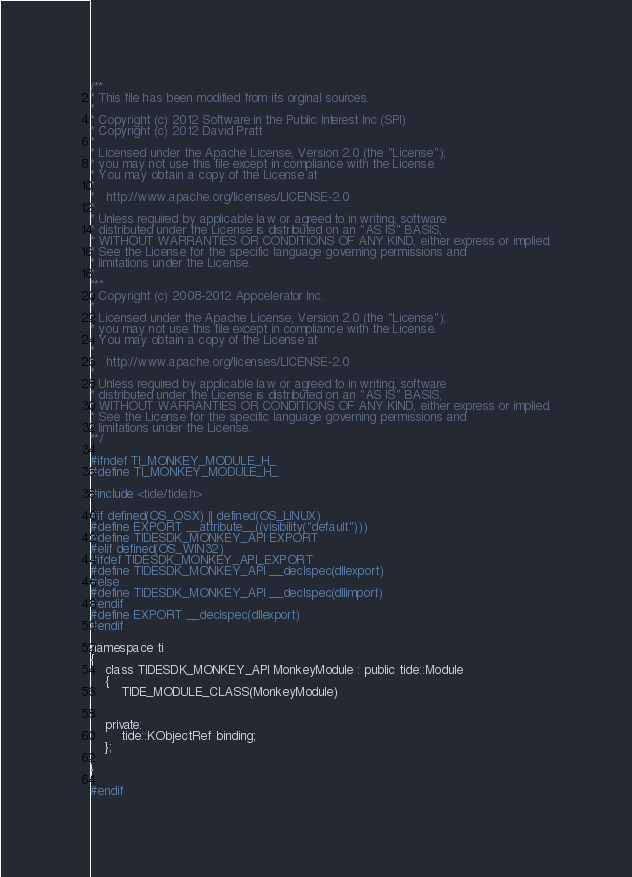<code> <loc_0><loc_0><loc_500><loc_500><_C_>/**
* This file has been modified from its orginal sources.
*
* Copyright (c) 2012 Software in the Public Interest Inc (SPI)
* Copyright (c) 2012 David Pratt
* 
* Licensed under the Apache License, Version 2.0 (the "License");
* you may not use this file except in compliance with the License.
* You may obtain a copy of the License at
*
*   http://www.apache.org/licenses/LICENSE-2.0
*
* Unless required by applicable law or agreed to in writing, software
* distributed under the License is distributed on an "AS IS" BASIS,
* WITHOUT WARRANTIES OR CONDITIONS OF ANY KIND, either express or implied.
* See the License for the specific language governing permissions and
* limitations under the License.
*
***
* Copyright (c) 2008-2012 Appcelerator Inc.
* 
* Licensed under the Apache License, Version 2.0 (the "License");
* you may not use this file except in compliance with the License.
* You may obtain a copy of the License at
*
*   http://www.apache.org/licenses/LICENSE-2.0
*
* Unless required by applicable law or agreed to in writing, software
* distributed under the License is distributed on an "AS IS" BASIS,
* WITHOUT WARRANTIES OR CONDITIONS OF ANY KIND, either express or implied.
* See the License for the specific language governing permissions and
* limitations under the License.
**/

#ifndef TI_MONKEY_MODULE_H_
#define TI_MONKEY_MODULE_H_

#include <tide/tide.h>

#if defined(OS_OSX) || defined(OS_LINUX)
#define EXPORT __attribute__((visibility("default")))
#define TIDESDK_MONKEY_API EXPORT
#elif defined(OS_WIN32)
#ifdef TIDESDK_MONKEY_API_EXPORT
#define TIDESDK_MONKEY_API __declspec(dllexport)
#else
#define TIDESDK_MONKEY_API __declspec(dllimport)
#endif
#define EXPORT __declspec(dllexport)
#endif

namespace ti 
{
    class TIDESDK_MONKEY_API MonkeyModule : public tide::Module
    {
        TIDE_MODULE_CLASS(MonkeyModule)
        

    private:
        tide::KObjectRef binding;
    };

}

#endif
</code> 